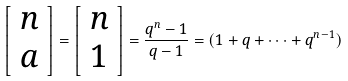<formula> <loc_0><loc_0><loc_500><loc_500>\left [ \begin{array} { c } n \\ a \end{array} \right ] = \left [ \begin{array} { c } n \\ 1 \end{array} \right ] = \frac { q ^ { n } - 1 } { q - 1 } = ( 1 + q + \dots + q ^ { n - 1 } )</formula> 